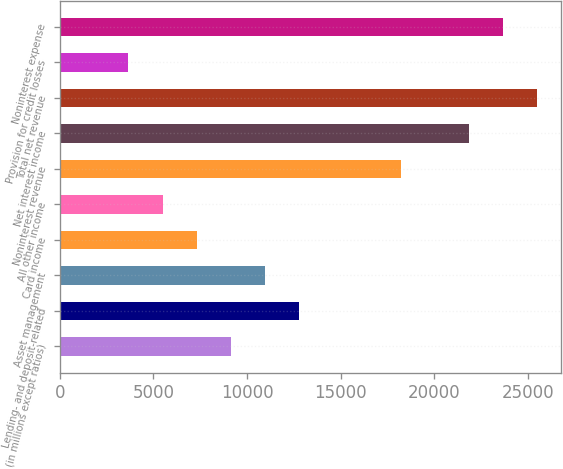<chart> <loc_0><loc_0><loc_500><loc_500><bar_chart><fcel>(in millions except ratios)<fcel>Lending- and deposit-related<fcel>Asset management<fcel>Card income<fcel>All other income<fcel>Noninterest revenue<fcel>Net interest income<fcel>Total net revenue<fcel>Provision for credit losses<fcel>Noninterest expense<nl><fcel>9128.5<fcel>12767.5<fcel>10948<fcel>7309<fcel>5489.5<fcel>18226<fcel>21865<fcel>25504<fcel>3670<fcel>23684.5<nl></chart> 